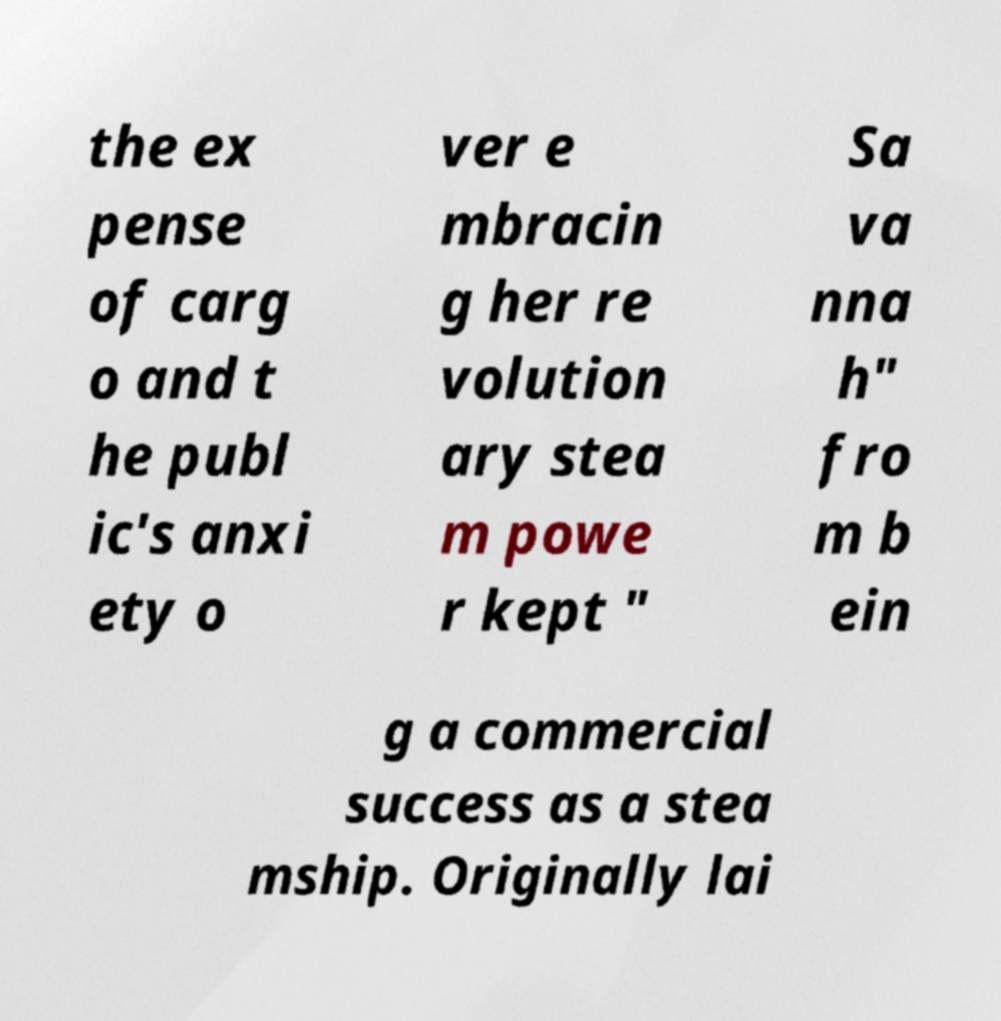For documentation purposes, I need the text within this image transcribed. Could you provide that? the ex pense of carg o and t he publ ic's anxi ety o ver e mbracin g her re volution ary stea m powe r kept " Sa va nna h" fro m b ein g a commercial success as a stea mship. Originally lai 